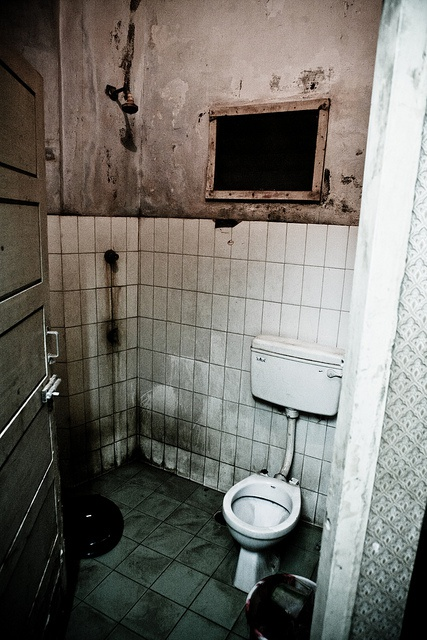Describe the objects in this image and their specific colors. I can see a toilet in black, lightgray, and darkgray tones in this image. 